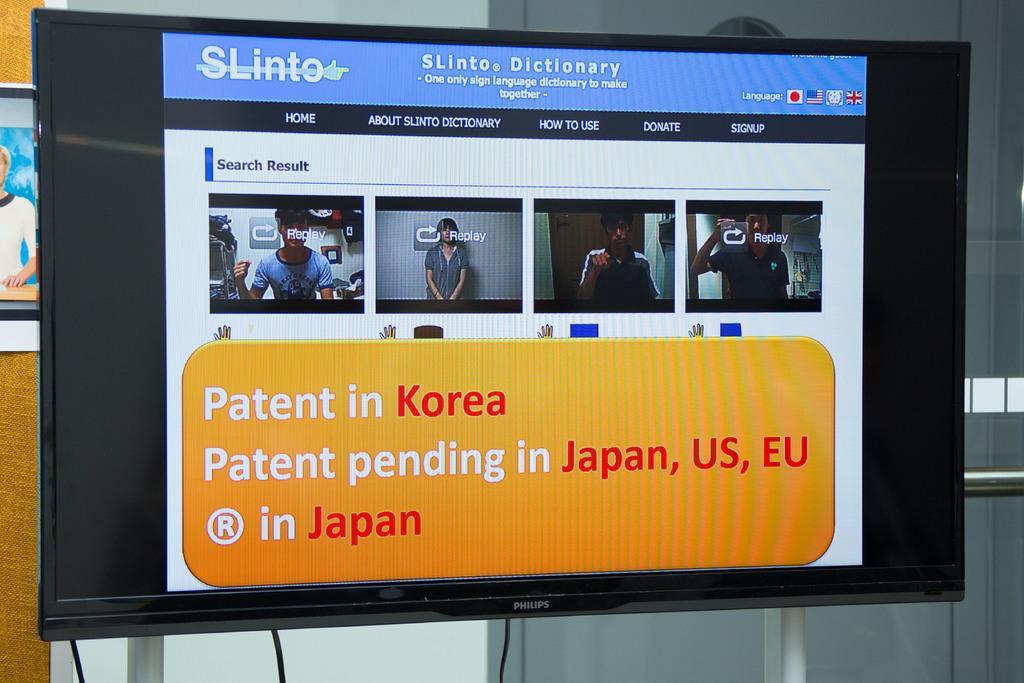In one or two sentences, can you explain what this image depicts? In this image, I can see a television screen with the display. In the background, there is a glass door and an iron pole. On the left side of the image, It looks like a poster. At the bottom of the image, I can see the wires hanging. 